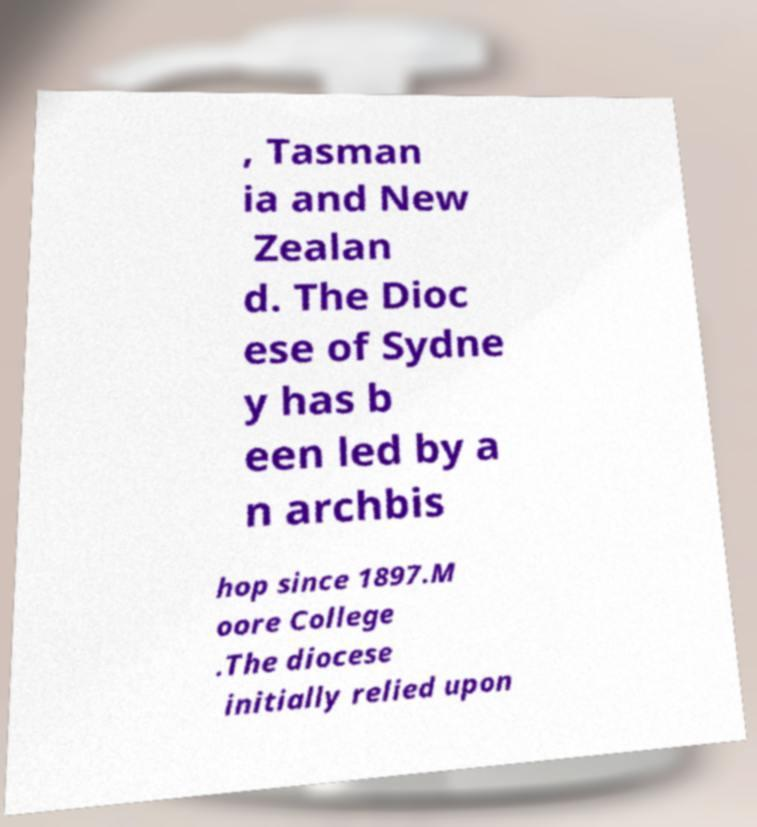Could you assist in decoding the text presented in this image and type it out clearly? , Tasman ia and New Zealan d. The Dioc ese of Sydne y has b een led by a n archbis hop since 1897.M oore College .The diocese initially relied upon 